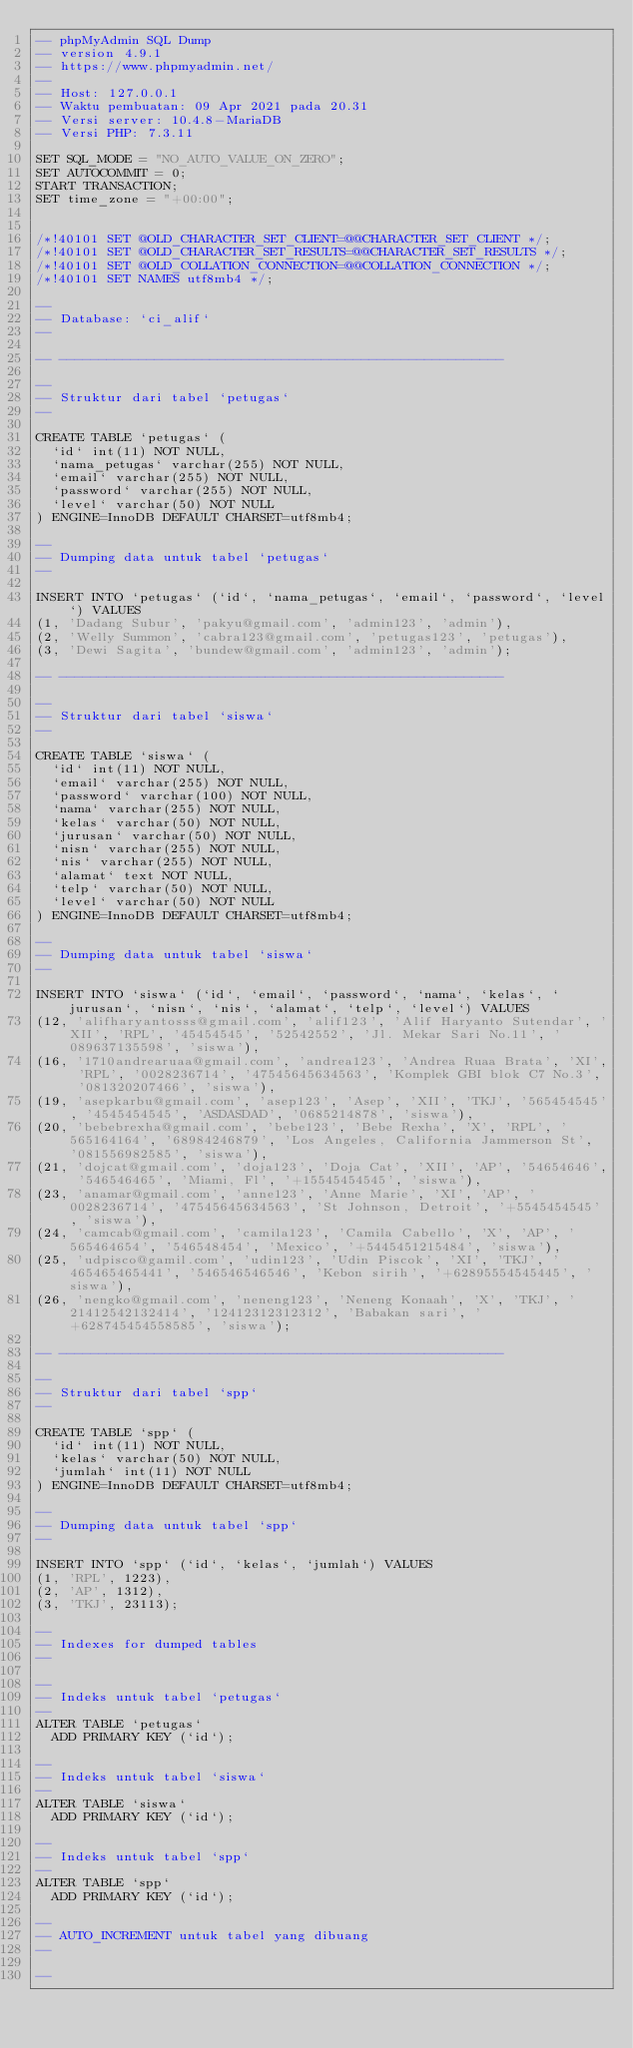<code> <loc_0><loc_0><loc_500><loc_500><_SQL_>-- phpMyAdmin SQL Dump
-- version 4.9.1
-- https://www.phpmyadmin.net/
--
-- Host: 127.0.0.1
-- Waktu pembuatan: 09 Apr 2021 pada 20.31
-- Versi server: 10.4.8-MariaDB
-- Versi PHP: 7.3.11

SET SQL_MODE = "NO_AUTO_VALUE_ON_ZERO";
SET AUTOCOMMIT = 0;
START TRANSACTION;
SET time_zone = "+00:00";


/*!40101 SET @OLD_CHARACTER_SET_CLIENT=@@CHARACTER_SET_CLIENT */;
/*!40101 SET @OLD_CHARACTER_SET_RESULTS=@@CHARACTER_SET_RESULTS */;
/*!40101 SET @OLD_COLLATION_CONNECTION=@@COLLATION_CONNECTION */;
/*!40101 SET NAMES utf8mb4 */;

--
-- Database: `ci_alif`
--

-- --------------------------------------------------------

--
-- Struktur dari tabel `petugas`
--

CREATE TABLE `petugas` (
  `id` int(11) NOT NULL,
  `nama_petugas` varchar(255) NOT NULL,
  `email` varchar(255) NOT NULL,
  `password` varchar(255) NOT NULL,
  `level` varchar(50) NOT NULL
) ENGINE=InnoDB DEFAULT CHARSET=utf8mb4;

--
-- Dumping data untuk tabel `petugas`
--

INSERT INTO `petugas` (`id`, `nama_petugas`, `email`, `password`, `level`) VALUES
(1, 'Dadang Subur', 'pakyu@gmail.com', 'admin123', 'admin'),
(2, 'Welly Summon', 'cabra123@gmail.com', 'petugas123', 'petugas'),
(3, 'Dewi Sagita', 'bundew@gmail.com', 'admin123', 'admin');

-- --------------------------------------------------------

--
-- Struktur dari tabel `siswa`
--

CREATE TABLE `siswa` (
  `id` int(11) NOT NULL,
  `email` varchar(255) NOT NULL,
  `password` varchar(100) NOT NULL,
  `nama` varchar(255) NOT NULL,
  `kelas` varchar(50) NOT NULL,
  `jurusan` varchar(50) NOT NULL,
  `nisn` varchar(255) NOT NULL,
  `nis` varchar(255) NOT NULL,
  `alamat` text NOT NULL,
  `telp` varchar(50) NOT NULL,
  `level` varchar(50) NOT NULL
) ENGINE=InnoDB DEFAULT CHARSET=utf8mb4;

--
-- Dumping data untuk tabel `siswa`
--

INSERT INTO `siswa` (`id`, `email`, `password`, `nama`, `kelas`, `jurusan`, `nisn`, `nis`, `alamat`, `telp`, `level`) VALUES
(12, 'alifharyantosss@gmail.com', 'alif123', 'Alif Haryanto Sutendar', 'XII', 'RPL', '45454545', '52542552', 'Jl. Mekar Sari No.11', '089637135598', 'siswa'),
(16, '1710andrearuaa@gmail.com', 'andrea123', 'Andrea Ruaa Brata', 'XI', 'RPL', '0028236714', '47545645634563', 'Komplek GBI blok C7 No.3', '081320207466', 'siswa'),
(19, 'asepkarbu@gmail.com', 'asep123', 'Asep', 'XII', 'TKJ', '565454545', '4545454545', 'ASDASDAD', '0685214878', 'siswa'),
(20, 'bebebrexha@gmail.com', 'bebe123', 'Bebe Rexha', 'X', 'RPL', '565164164', '68984246879', 'Los Angeles, California Jammerson St', '081556982585', 'siswa'),
(21, 'dojcat@gmail.com', 'doja123', 'Doja Cat', 'XII', 'AP', '54654646', '546546465', 'Miami, Fl', '+15545454545', 'siswa'),
(23, 'anamar@gmail.com', 'anne123', 'Anne Marie', 'XI', 'AP', '0028236714', '47545645634563', 'St Johnson, Detroit', '+5545454545', 'siswa'),
(24, 'camcab@gmail.com', 'camila123', 'Camila Cabello', 'X', 'AP', '565464654', '546548454', 'Mexico', '+5445451215484', 'siswa'),
(25, 'udpisco@gamil.com', 'udin123', 'Udin Piscok', 'XI', 'TKJ', '465465465441', '546546546546', 'Kebon sirih', '+62895554545445', 'siswa'),
(26, 'nengko@gmail.com', 'neneng123', 'Neneng Konaah', 'X', 'TKJ', '21412542132414', '12412312312312', 'Babakan sari', '+628745454558585', 'siswa');

-- --------------------------------------------------------

--
-- Struktur dari tabel `spp`
--

CREATE TABLE `spp` (
  `id` int(11) NOT NULL,
  `kelas` varchar(50) NOT NULL,
  `jumlah` int(11) NOT NULL
) ENGINE=InnoDB DEFAULT CHARSET=utf8mb4;

--
-- Dumping data untuk tabel `spp`
--

INSERT INTO `spp` (`id`, `kelas`, `jumlah`) VALUES
(1, 'RPL', 1223),
(2, 'AP', 1312),
(3, 'TKJ', 23113);

--
-- Indexes for dumped tables
--

--
-- Indeks untuk tabel `petugas`
--
ALTER TABLE `petugas`
  ADD PRIMARY KEY (`id`);

--
-- Indeks untuk tabel `siswa`
--
ALTER TABLE `siswa`
  ADD PRIMARY KEY (`id`);

--
-- Indeks untuk tabel `spp`
--
ALTER TABLE `spp`
  ADD PRIMARY KEY (`id`);

--
-- AUTO_INCREMENT untuk tabel yang dibuang
--

--</code> 